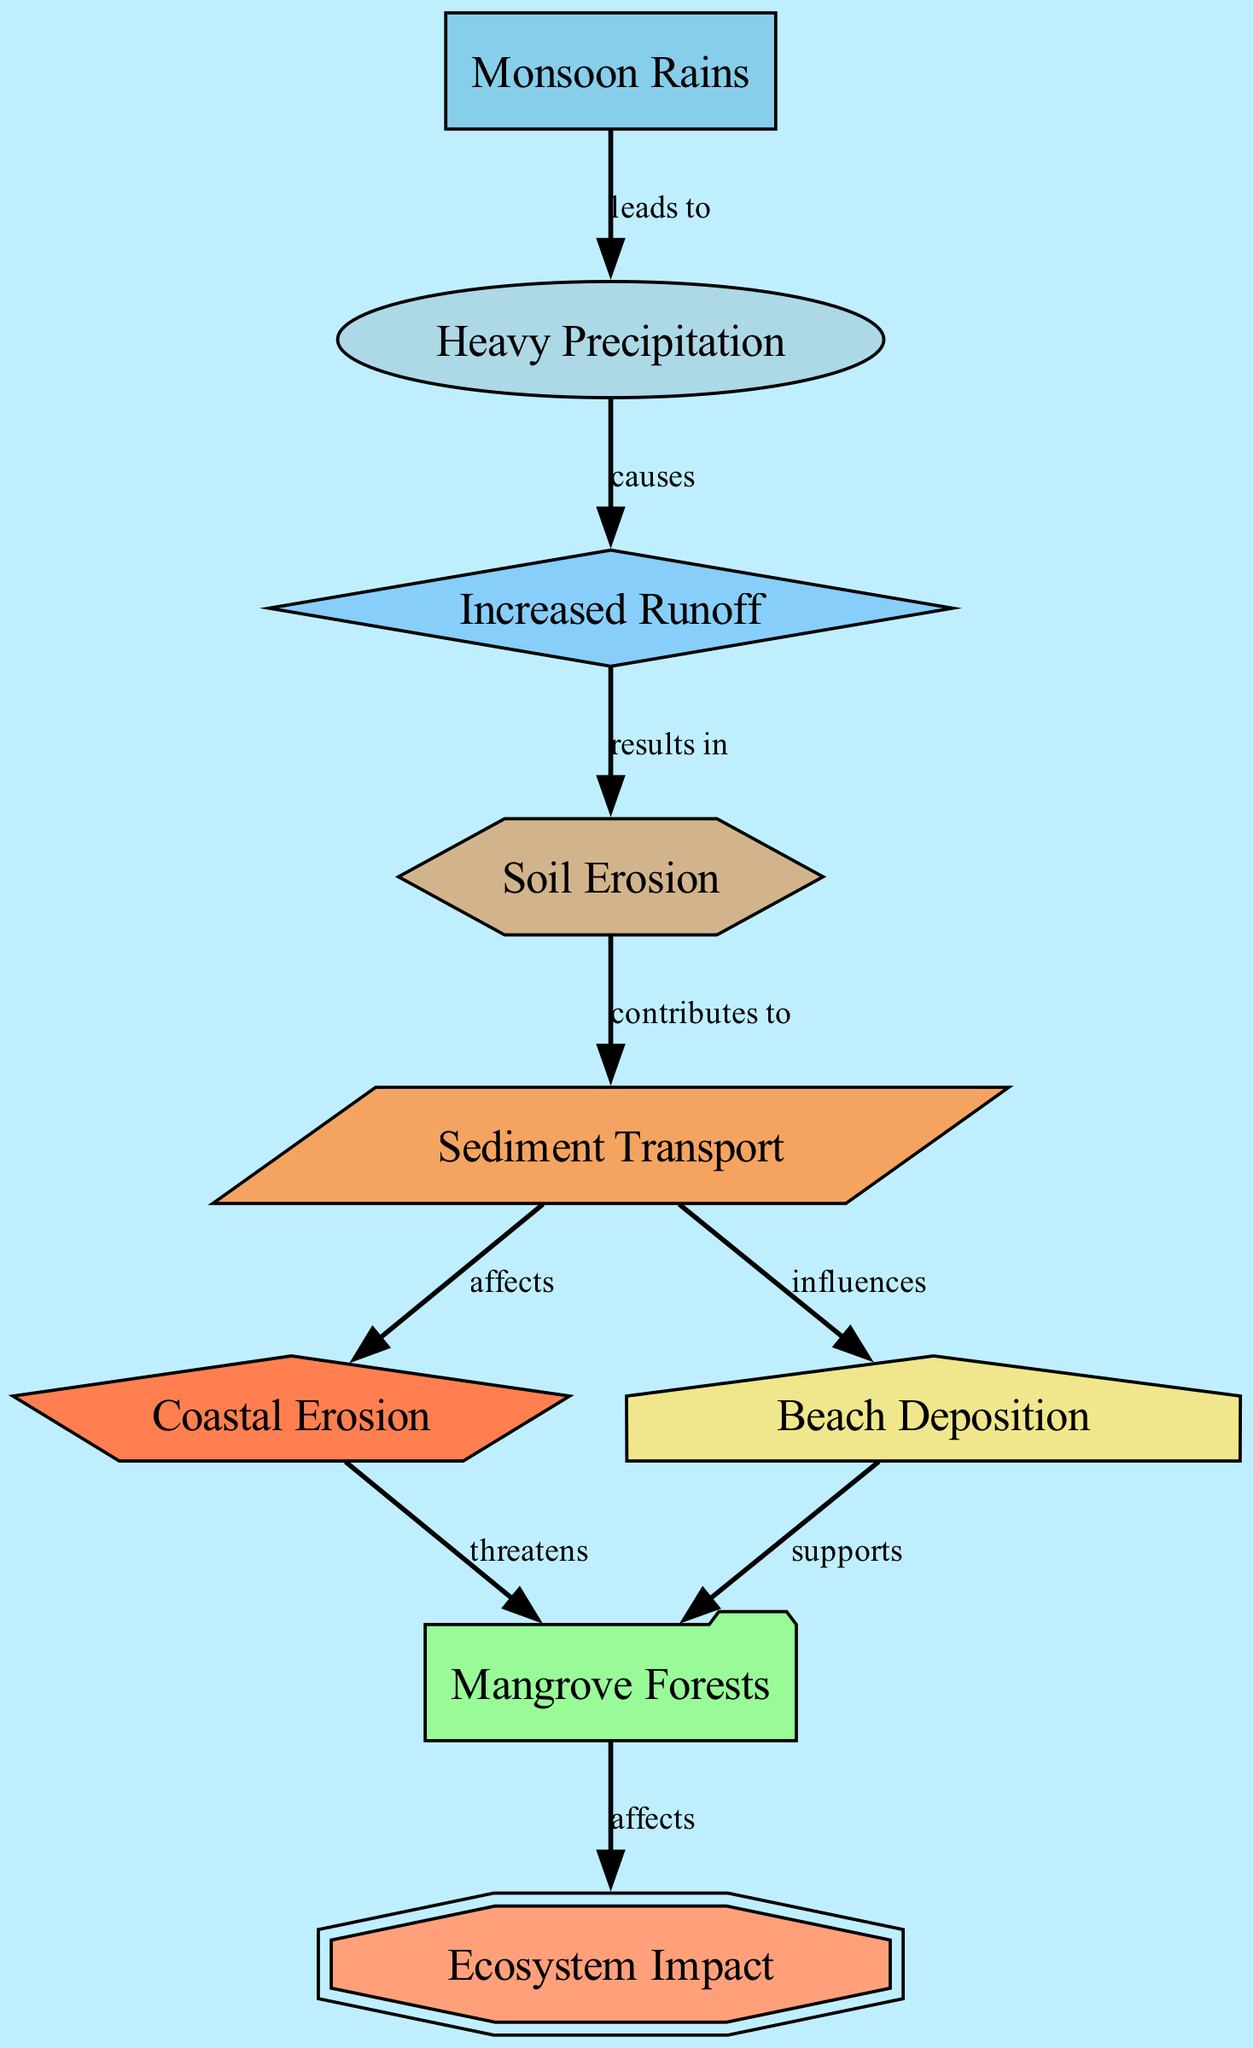What is the first node in the diagram? The first node in the diagram is "Monsoon Rains," which is positioned at the top and serves as the starting point of the impact flow.
Answer: Monsoon Rains How many nodes are in the diagram? There are 9 nodes in the diagram, each representing different aspects of the effects of monsoons on soil erosion and coastal changes.
Answer: 9 What does "Heavy Precipitation" cause? "Heavy Precipitation" causes "Increased Runoff," as indicated by the directional edge connecting these two nodes in the diagram.
Answer: Increased Runoff Which node is threatened by Coastal Erosion? The node "Mangrove Forests" is threatened by "Coastal Erosion," as shown by the edge pointing from Coastal Erosion to Mangrove Forests in the diagram.
Answer: Mangrove Forests What influences Beach Deposition? The node "Sediment Transport" influences "Beach Deposition," as indicated by the arrow leading from Sediment Transport to Beach Deposition in the diagram.
Answer: Sediment Transport What is the relationship between Soil Erosion and Sediment Transport? "Soil Erosion" contributes to "Sediment Transport," reflecting the flow of impact as erosion leads to the movement of sediment.
Answer: contributes to How does Beach Deposition affect Mangrove Forests? "Beach Deposition" supports "Mangrove Forests," meaning that deposition processes contribute positively to the health of these ecosystems.
Answer: supports What impact does Mangrove Forests have on the ecosystem? "Mangrove Forests" affects the "Ecosystem Impact," indicating their crucial role in sustaining ecological balance and biodiversity.
Answer: affects What happens after Increased Runoff? After "Increased Runoff," the next effect is "Soil Erosion," demonstrating the sequential impact of heavy rainfall.
Answer: Soil Erosion 